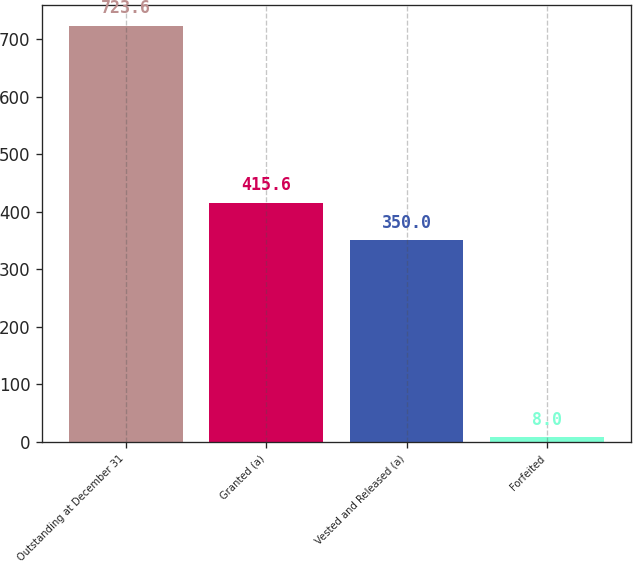Convert chart to OTSL. <chart><loc_0><loc_0><loc_500><loc_500><bar_chart><fcel>Outstanding at December 31<fcel>Granted (a)<fcel>Vested and Released (a)<fcel>Forfeited<nl><fcel>723.6<fcel>415.6<fcel>350<fcel>8<nl></chart> 